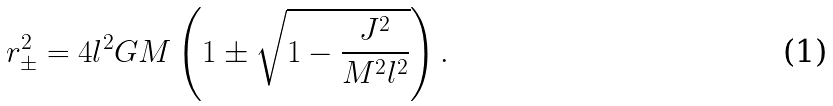Convert formula to latex. <formula><loc_0><loc_0><loc_500><loc_500>r _ { \pm } ^ { 2 } = 4 l ^ { 2 } G M \left ( 1 \pm \sqrt { 1 - \frac { J ^ { 2 } } { M ^ { 2 } l ^ { 2 } } } \right ) .</formula> 